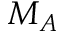<formula> <loc_0><loc_0><loc_500><loc_500>M _ { A }</formula> 